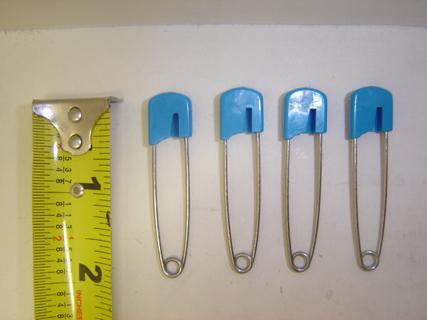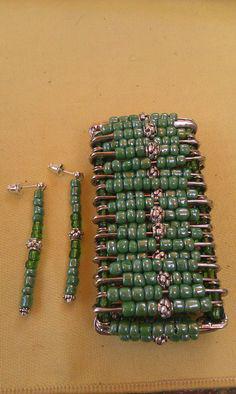The first image is the image on the left, the second image is the image on the right. For the images shown, is this caption "There is one open safety pin." true? Answer yes or no. No. The first image is the image on the left, the second image is the image on the right. For the images displayed, is the sentence "In one image a safety pin is open." factually correct? Answer yes or no. No. 